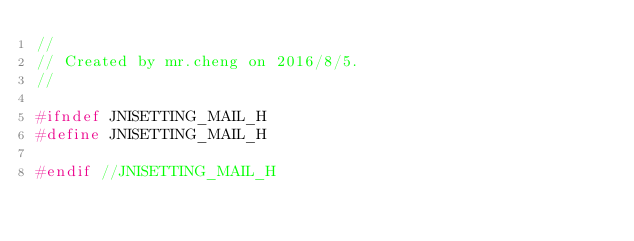Convert code to text. <code><loc_0><loc_0><loc_500><loc_500><_C_>//
// Created by mr.cheng on 2016/8/5.
//

#ifndef JNISETTING_MAIL_H
#define JNISETTING_MAIL_H

#endif //JNISETTING_MAIL_H
</code> 